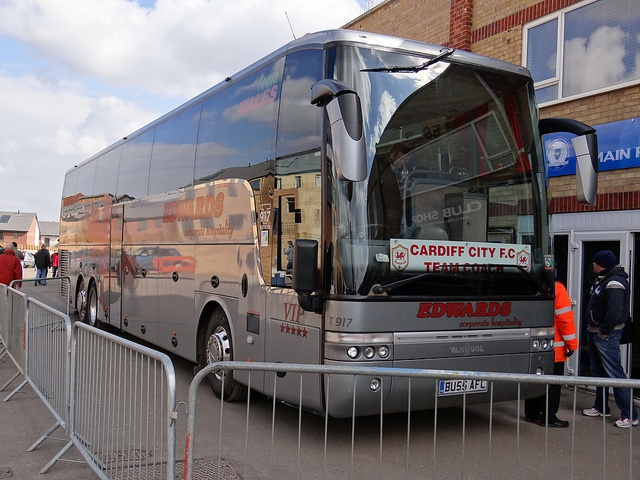Describe the objects in this image and their specific colors. I can see bus in lavender, black, gray, and darkgray tones, people in lavender, black, gray, navy, and darkgray tones, people in lavender, black, red, gray, and darkgray tones, people in lavender, black, and gray tones, and people in lavender, maroon, and gray tones in this image. 